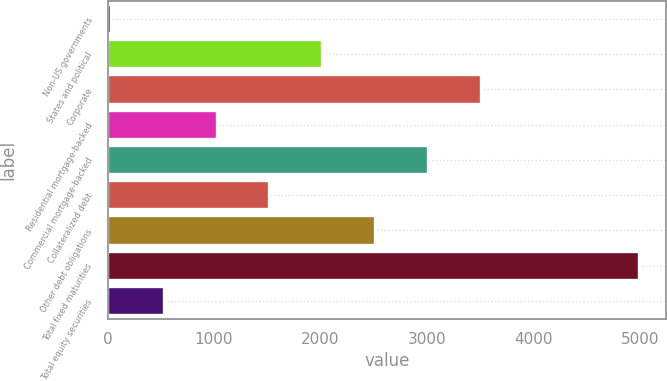Convert chart. <chart><loc_0><loc_0><loc_500><loc_500><bar_chart><fcel>Non-US governments<fcel>States and political<fcel>Corporate<fcel>Residential mortgage-backed<fcel>Commercial mortgage-backed<fcel>Collateralized debt<fcel>Other debt obligations<fcel>Total fixed maturities<fcel>Total equity securities<nl><fcel>30.7<fcel>2017.18<fcel>3507.04<fcel>1023.94<fcel>3010.42<fcel>1520.56<fcel>2513.8<fcel>4996.9<fcel>527.32<nl></chart> 